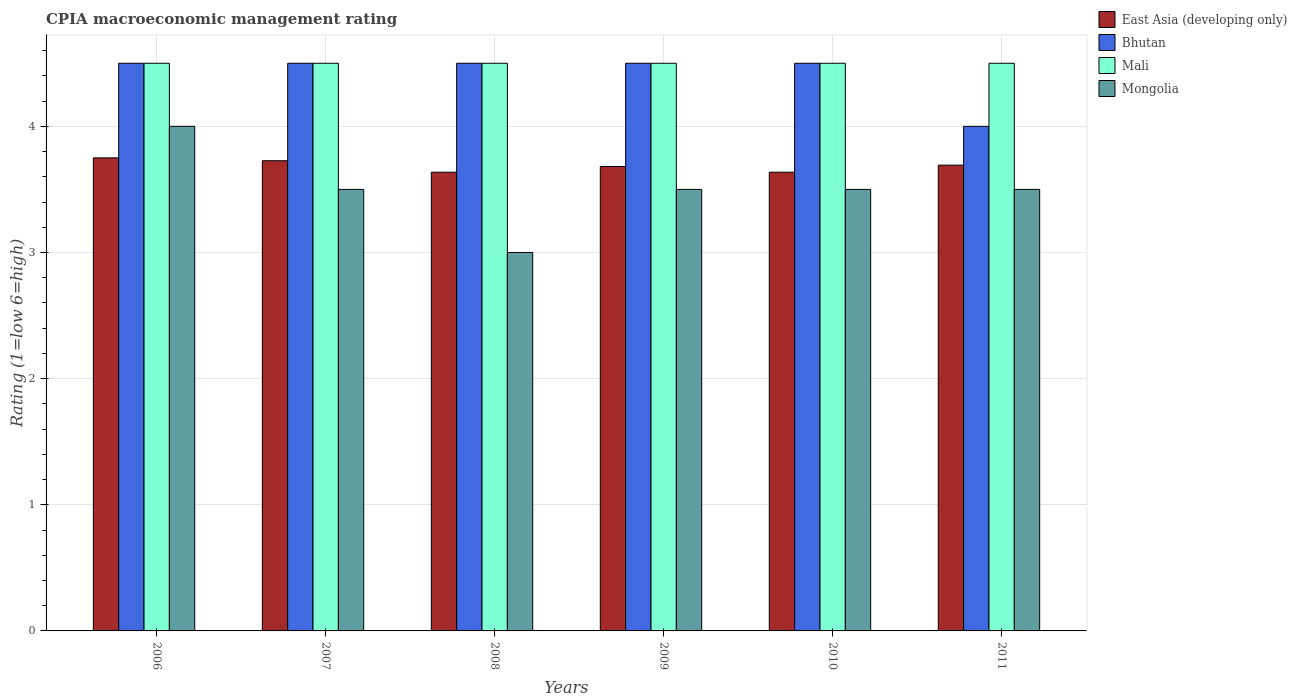How many groups of bars are there?
Offer a very short reply. 6. Are the number of bars per tick equal to the number of legend labels?
Ensure brevity in your answer.  Yes. Are the number of bars on each tick of the X-axis equal?
Provide a succinct answer. Yes. How many bars are there on the 4th tick from the right?
Your answer should be very brief. 4. In how many cases, is the number of bars for a given year not equal to the number of legend labels?
Provide a short and direct response. 0. What is the CPIA rating in East Asia (developing only) in 2006?
Provide a short and direct response. 3.75. Across all years, what is the minimum CPIA rating in Bhutan?
Offer a terse response. 4. In which year was the CPIA rating in Mongolia maximum?
Offer a very short reply. 2006. In which year was the CPIA rating in Mongolia minimum?
Give a very brief answer. 2008. What is the total CPIA rating in East Asia (developing only) in the graph?
Keep it short and to the point. 22.12. What is the difference between the CPIA rating in Mongolia in 2011 and the CPIA rating in Bhutan in 2007?
Your response must be concise. -1. In the year 2008, what is the difference between the CPIA rating in Mongolia and CPIA rating in Mali?
Keep it short and to the point. -1.5. In how many years, is the CPIA rating in Mali greater than 3?
Provide a short and direct response. 6. What is the ratio of the CPIA rating in Bhutan in 2008 to that in 2010?
Provide a succinct answer. 1. Is the CPIA rating in East Asia (developing only) in 2007 less than that in 2011?
Offer a terse response. No. Is the difference between the CPIA rating in Mongolia in 2010 and 2011 greater than the difference between the CPIA rating in Mali in 2010 and 2011?
Keep it short and to the point. No. What is the difference between the highest and the lowest CPIA rating in East Asia (developing only)?
Keep it short and to the point. 0.11. In how many years, is the CPIA rating in Mali greater than the average CPIA rating in Mali taken over all years?
Ensure brevity in your answer.  0. Is the sum of the CPIA rating in Mali in 2006 and 2009 greater than the maximum CPIA rating in Bhutan across all years?
Give a very brief answer. Yes. What does the 4th bar from the left in 2010 represents?
Keep it short and to the point. Mongolia. What does the 4th bar from the right in 2010 represents?
Offer a terse response. East Asia (developing only). Is it the case that in every year, the sum of the CPIA rating in East Asia (developing only) and CPIA rating in Mali is greater than the CPIA rating in Mongolia?
Your response must be concise. Yes. What is the difference between two consecutive major ticks on the Y-axis?
Your answer should be very brief. 1. Are the values on the major ticks of Y-axis written in scientific E-notation?
Your answer should be compact. No. Where does the legend appear in the graph?
Offer a terse response. Top right. What is the title of the graph?
Give a very brief answer. CPIA macroeconomic management rating. What is the label or title of the X-axis?
Provide a succinct answer. Years. What is the Rating (1=low 6=high) of East Asia (developing only) in 2006?
Offer a terse response. 3.75. What is the Rating (1=low 6=high) in Mongolia in 2006?
Provide a short and direct response. 4. What is the Rating (1=low 6=high) of East Asia (developing only) in 2007?
Ensure brevity in your answer.  3.73. What is the Rating (1=low 6=high) in Mongolia in 2007?
Give a very brief answer. 3.5. What is the Rating (1=low 6=high) in East Asia (developing only) in 2008?
Keep it short and to the point. 3.64. What is the Rating (1=low 6=high) of Bhutan in 2008?
Your answer should be very brief. 4.5. What is the Rating (1=low 6=high) of Mongolia in 2008?
Provide a succinct answer. 3. What is the Rating (1=low 6=high) in East Asia (developing only) in 2009?
Keep it short and to the point. 3.68. What is the Rating (1=low 6=high) of Mongolia in 2009?
Provide a succinct answer. 3.5. What is the Rating (1=low 6=high) of East Asia (developing only) in 2010?
Offer a terse response. 3.64. What is the Rating (1=low 6=high) in Bhutan in 2010?
Provide a short and direct response. 4.5. What is the Rating (1=low 6=high) in Mongolia in 2010?
Offer a terse response. 3.5. What is the Rating (1=low 6=high) in East Asia (developing only) in 2011?
Ensure brevity in your answer.  3.69. What is the Rating (1=low 6=high) of Mali in 2011?
Offer a terse response. 4.5. What is the Rating (1=low 6=high) of Mongolia in 2011?
Provide a succinct answer. 3.5. Across all years, what is the maximum Rating (1=low 6=high) in East Asia (developing only)?
Your response must be concise. 3.75. Across all years, what is the maximum Rating (1=low 6=high) of Bhutan?
Your answer should be compact. 4.5. Across all years, what is the minimum Rating (1=low 6=high) in East Asia (developing only)?
Keep it short and to the point. 3.64. Across all years, what is the minimum Rating (1=low 6=high) in Bhutan?
Your answer should be compact. 4. What is the total Rating (1=low 6=high) in East Asia (developing only) in the graph?
Provide a succinct answer. 22.12. What is the total Rating (1=low 6=high) in Mali in the graph?
Provide a short and direct response. 27. What is the difference between the Rating (1=low 6=high) in East Asia (developing only) in 2006 and that in 2007?
Make the answer very short. 0.02. What is the difference between the Rating (1=low 6=high) in Bhutan in 2006 and that in 2007?
Your response must be concise. 0. What is the difference between the Rating (1=low 6=high) in Mali in 2006 and that in 2007?
Your answer should be compact. 0. What is the difference between the Rating (1=low 6=high) in Mongolia in 2006 and that in 2007?
Your answer should be very brief. 0.5. What is the difference between the Rating (1=low 6=high) in East Asia (developing only) in 2006 and that in 2008?
Provide a succinct answer. 0.11. What is the difference between the Rating (1=low 6=high) in Bhutan in 2006 and that in 2008?
Provide a succinct answer. 0. What is the difference between the Rating (1=low 6=high) of East Asia (developing only) in 2006 and that in 2009?
Your answer should be very brief. 0.07. What is the difference between the Rating (1=low 6=high) of Mongolia in 2006 and that in 2009?
Give a very brief answer. 0.5. What is the difference between the Rating (1=low 6=high) in East Asia (developing only) in 2006 and that in 2010?
Offer a very short reply. 0.11. What is the difference between the Rating (1=low 6=high) of Bhutan in 2006 and that in 2010?
Offer a very short reply. 0. What is the difference between the Rating (1=low 6=high) in Mali in 2006 and that in 2010?
Offer a terse response. 0. What is the difference between the Rating (1=low 6=high) in Mongolia in 2006 and that in 2010?
Keep it short and to the point. 0.5. What is the difference between the Rating (1=low 6=high) of East Asia (developing only) in 2006 and that in 2011?
Give a very brief answer. 0.06. What is the difference between the Rating (1=low 6=high) of Bhutan in 2006 and that in 2011?
Give a very brief answer. 0.5. What is the difference between the Rating (1=low 6=high) of Mongolia in 2006 and that in 2011?
Ensure brevity in your answer.  0.5. What is the difference between the Rating (1=low 6=high) in East Asia (developing only) in 2007 and that in 2008?
Ensure brevity in your answer.  0.09. What is the difference between the Rating (1=low 6=high) in Bhutan in 2007 and that in 2008?
Offer a terse response. 0. What is the difference between the Rating (1=low 6=high) of Mali in 2007 and that in 2008?
Give a very brief answer. 0. What is the difference between the Rating (1=low 6=high) of Mongolia in 2007 and that in 2008?
Your answer should be compact. 0.5. What is the difference between the Rating (1=low 6=high) of East Asia (developing only) in 2007 and that in 2009?
Provide a short and direct response. 0.05. What is the difference between the Rating (1=low 6=high) of Mali in 2007 and that in 2009?
Your answer should be compact. 0. What is the difference between the Rating (1=low 6=high) in Mongolia in 2007 and that in 2009?
Your response must be concise. 0. What is the difference between the Rating (1=low 6=high) of East Asia (developing only) in 2007 and that in 2010?
Provide a short and direct response. 0.09. What is the difference between the Rating (1=low 6=high) in Mali in 2007 and that in 2010?
Keep it short and to the point. 0. What is the difference between the Rating (1=low 6=high) of East Asia (developing only) in 2007 and that in 2011?
Ensure brevity in your answer.  0.04. What is the difference between the Rating (1=low 6=high) in Bhutan in 2007 and that in 2011?
Your answer should be very brief. 0.5. What is the difference between the Rating (1=low 6=high) of Mali in 2007 and that in 2011?
Your answer should be very brief. 0. What is the difference between the Rating (1=low 6=high) in East Asia (developing only) in 2008 and that in 2009?
Provide a short and direct response. -0.05. What is the difference between the Rating (1=low 6=high) in Mali in 2008 and that in 2009?
Offer a terse response. 0. What is the difference between the Rating (1=low 6=high) of Mongolia in 2008 and that in 2009?
Ensure brevity in your answer.  -0.5. What is the difference between the Rating (1=low 6=high) of East Asia (developing only) in 2008 and that in 2010?
Keep it short and to the point. 0. What is the difference between the Rating (1=low 6=high) in Mali in 2008 and that in 2010?
Offer a terse response. 0. What is the difference between the Rating (1=low 6=high) in Mongolia in 2008 and that in 2010?
Provide a succinct answer. -0.5. What is the difference between the Rating (1=low 6=high) in East Asia (developing only) in 2008 and that in 2011?
Give a very brief answer. -0.06. What is the difference between the Rating (1=low 6=high) of East Asia (developing only) in 2009 and that in 2010?
Offer a terse response. 0.05. What is the difference between the Rating (1=low 6=high) in Bhutan in 2009 and that in 2010?
Ensure brevity in your answer.  0. What is the difference between the Rating (1=low 6=high) in Mali in 2009 and that in 2010?
Provide a short and direct response. 0. What is the difference between the Rating (1=low 6=high) of Mongolia in 2009 and that in 2010?
Keep it short and to the point. 0. What is the difference between the Rating (1=low 6=high) of East Asia (developing only) in 2009 and that in 2011?
Your answer should be compact. -0.01. What is the difference between the Rating (1=low 6=high) in Bhutan in 2009 and that in 2011?
Ensure brevity in your answer.  0.5. What is the difference between the Rating (1=low 6=high) in Mali in 2009 and that in 2011?
Your answer should be compact. 0. What is the difference between the Rating (1=low 6=high) of East Asia (developing only) in 2010 and that in 2011?
Your answer should be very brief. -0.06. What is the difference between the Rating (1=low 6=high) of Mongolia in 2010 and that in 2011?
Offer a very short reply. 0. What is the difference between the Rating (1=low 6=high) in East Asia (developing only) in 2006 and the Rating (1=low 6=high) in Bhutan in 2007?
Your answer should be compact. -0.75. What is the difference between the Rating (1=low 6=high) in East Asia (developing only) in 2006 and the Rating (1=low 6=high) in Mali in 2007?
Provide a succinct answer. -0.75. What is the difference between the Rating (1=low 6=high) in Mali in 2006 and the Rating (1=low 6=high) in Mongolia in 2007?
Your answer should be very brief. 1. What is the difference between the Rating (1=low 6=high) in East Asia (developing only) in 2006 and the Rating (1=low 6=high) in Bhutan in 2008?
Make the answer very short. -0.75. What is the difference between the Rating (1=low 6=high) in East Asia (developing only) in 2006 and the Rating (1=low 6=high) in Mali in 2008?
Offer a very short reply. -0.75. What is the difference between the Rating (1=low 6=high) in Mali in 2006 and the Rating (1=low 6=high) in Mongolia in 2008?
Make the answer very short. 1.5. What is the difference between the Rating (1=low 6=high) in East Asia (developing only) in 2006 and the Rating (1=low 6=high) in Bhutan in 2009?
Your answer should be very brief. -0.75. What is the difference between the Rating (1=low 6=high) of East Asia (developing only) in 2006 and the Rating (1=low 6=high) of Mali in 2009?
Keep it short and to the point. -0.75. What is the difference between the Rating (1=low 6=high) of East Asia (developing only) in 2006 and the Rating (1=low 6=high) of Mongolia in 2009?
Offer a terse response. 0.25. What is the difference between the Rating (1=low 6=high) in Bhutan in 2006 and the Rating (1=low 6=high) in Mali in 2009?
Give a very brief answer. 0. What is the difference between the Rating (1=low 6=high) in Bhutan in 2006 and the Rating (1=low 6=high) in Mongolia in 2009?
Give a very brief answer. 1. What is the difference between the Rating (1=low 6=high) of East Asia (developing only) in 2006 and the Rating (1=low 6=high) of Bhutan in 2010?
Your answer should be compact. -0.75. What is the difference between the Rating (1=low 6=high) in East Asia (developing only) in 2006 and the Rating (1=low 6=high) in Mali in 2010?
Offer a very short reply. -0.75. What is the difference between the Rating (1=low 6=high) of East Asia (developing only) in 2006 and the Rating (1=low 6=high) of Mongolia in 2010?
Offer a terse response. 0.25. What is the difference between the Rating (1=low 6=high) of Mali in 2006 and the Rating (1=low 6=high) of Mongolia in 2010?
Your answer should be very brief. 1. What is the difference between the Rating (1=low 6=high) of East Asia (developing only) in 2006 and the Rating (1=low 6=high) of Bhutan in 2011?
Ensure brevity in your answer.  -0.25. What is the difference between the Rating (1=low 6=high) of East Asia (developing only) in 2006 and the Rating (1=low 6=high) of Mali in 2011?
Give a very brief answer. -0.75. What is the difference between the Rating (1=low 6=high) in Bhutan in 2006 and the Rating (1=low 6=high) in Mali in 2011?
Your response must be concise. 0. What is the difference between the Rating (1=low 6=high) in Mali in 2006 and the Rating (1=low 6=high) in Mongolia in 2011?
Your response must be concise. 1. What is the difference between the Rating (1=low 6=high) in East Asia (developing only) in 2007 and the Rating (1=low 6=high) in Bhutan in 2008?
Your answer should be very brief. -0.77. What is the difference between the Rating (1=low 6=high) of East Asia (developing only) in 2007 and the Rating (1=low 6=high) of Mali in 2008?
Provide a succinct answer. -0.77. What is the difference between the Rating (1=low 6=high) of East Asia (developing only) in 2007 and the Rating (1=low 6=high) of Mongolia in 2008?
Provide a succinct answer. 0.73. What is the difference between the Rating (1=low 6=high) of Bhutan in 2007 and the Rating (1=low 6=high) of Mali in 2008?
Give a very brief answer. 0. What is the difference between the Rating (1=low 6=high) in Bhutan in 2007 and the Rating (1=low 6=high) in Mongolia in 2008?
Give a very brief answer. 1.5. What is the difference between the Rating (1=low 6=high) of East Asia (developing only) in 2007 and the Rating (1=low 6=high) of Bhutan in 2009?
Offer a very short reply. -0.77. What is the difference between the Rating (1=low 6=high) of East Asia (developing only) in 2007 and the Rating (1=low 6=high) of Mali in 2009?
Your answer should be very brief. -0.77. What is the difference between the Rating (1=low 6=high) in East Asia (developing only) in 2007 and the Rating (1=low 6=high) in Mongolia in 2009?
Make the answer very short. 0.23. What is the difference between the Rating (1=low 6=high) in Bhutan in 2007 and the Rating (1=low 6=high) in Mali in 2009?
Ensure brevity in your answer.  0. What is the difference between the Rating (1=low 6=high) of Bhutan in 2007 and the Rating (1=low 6=high) of Mongolia in 2009?
Provide a short and direct response. 1. What is the difference between the Rating (1=low 6=high) of Mali in 2007 and the Rating (1=low 6=high) of Mongolia in 2009?
Your answer should be compact. 1. What is the difference between the Rating (1=low 6=high) of East Asia (developing only) in 2007 and the Rating (1=low 6=high) of Bhutan in 2010?
Offer a very short reply. -0.77. What is the difference between the Rating (1=low 6=high) in East Asia (developing only) in 2007 and the Rating (1=low 6=high) in Mali in 2010?
Your response must be concise. -0.77. What is the difference between the Rating (1=low 6=high) of East Asia (developing only) in 2007 and the Rating (1=low 6=high) of Mongolia in 2010?
Make the answer very short. 0.23. What is the difference between the Rating (1=low 6=high) of Bhutan in 2007 and the Rating (1=low 6=high) of Mali in 2010?
Keep it short and to the point. 0. What is the difference between the Rating (1=low 6=high) in East Asia (developing only) in 2007 and the Rating (1=low 6=high) in Bhutan in 2011?
Offer a very short reply. -0.27. What is the difference between the Rating (1=low 6=high) in East Asia (developing only) in 2007 and the Rating (1=low 6=high) in Mali in 2011?
Keep it short and to the point. -0.77. What is the difference between the Rating (1=low 6=high) in East Asia (developing only) in 2007 and the Rating (1=low 6=high) in Mongolia in 2011?
Provide a succinct answer. 0.23. What is the difference between the Rating (1=low 6=high) of Bhutan in 2007 and the Rating (1=low 6=high) of Mali in 2011?
Ensure brevity in your answer.  0. What is the difference between the Rating (1=low 6=high) in Mali in 2007 and the Rating (1=low 6=high) in Mongolia in 2011?
Provide a succinct answer. 1. What is the difference between the Rating (1=low 6=high) in East Asia (developing only) in 2008 and the Rating (1=low 6=high) in Bhutan in 2009?
Make the answer very short. -0.86. What is the difference between the Rating (1=low 6=high) in East Asia (developing only) in 2008 and the Rating (1=low 6=high) in Mali in 2009?
Offer a terse response. -0.86. What is the difference between the Rating (1=low 6=high) in East Asia (developing only) in 2008 and the Rating (1=low 6=high) in Mongolia in 2009?
Give a very brief answer. 0.14. What is the difference between the Rating (1=low 6=high) in East Asia (developing only) in 2008 and the Rating (1=low 6=high) in Bhutan in 2010?
Keep it short and to the point. -0.86. What is the difference between the Rating (1=low 6=high) in East Asia (developing only) in 2008 and the Rating (1=low 6=high) in Mali in 2010?
Give a very brief answer. -0.86. What is the difference between the Rating (1=low 6=high) of East Asia (developing only) in 2008 and the Rating (1=low 6=high) of Mongolia in 2010?
Your answer should be very brief. 0.14. What is the difference between the Rating (1=low 6=high) in East Asia (developing only) in 2008 and the Rating (1=low 6=high) in Bhutan in 2011?
Make the answer very short. -0.36. What is the difference between the Rating (1=low 6=high) in East Asia (developing only) in 2008 and the Rating (1=low 6=high) in Mali in 2011?
Provide a short and direct response. -0.86. What is the difference between the Rating (1=low 6=high) of East Asia (developing only) in 2008 and the Rating (1=low 6=high) of Mongolia in 2011?
Provide a short and direct response. 0.14. What is the difference between the Rating (1=low 6=high) in Bhutan in 2008 and the Rating (1=low 6=high) in Mali in 2011?
Ensure brevity in your answer.  0. What is the difference between the Rating (1=low 6=high) in Mali in 2008 and the Rating (1=low 6=high) in Mongolia in 2011?
Provide a succinct answer. 1. What is the difference between the Rating (1=low 6=high) of East Asia (developing only) in 2009 and the Rating (1=low 6=high) of Bhutan in 2010?
Offer a very short reply. -0.82. What is the difference between the Rating (1=low 6=high) in East Asia (developing only) in 2009 and the Rating (1=low 6=high) in Mali in 2010?
Provide a succinct answer. -0.82. What is the difference between the Rating (1=low 6=high) in East Asia (developing only) in 2009 and the Rating (1=low 6=high) in Mongolia in 2010?
Make the answer very short. 0.18. What is the difference between the Rating (1=low 6=high) in Bhutan in 2009 and the Rating (1=low 6=high) in Mongolia in 2010?
Give a very brief answer. 1. What is the difference between the Rating (1=low 6=high) in East Asia (developing only) in 2009 and the Rating (1=low 6=high) in Bhutan in 2011?
Provide a succinct answer. -0.32. What is the difference between the Rating (1=low 6=high) in East Asia (developing only) in 2009 and the Rating (1=low 6=high) in Mali in 2011?
Provide a short and direct response. -0.82. What is the difference between the Rating (1=low 6=high) in East Asia (developing only) in 2009 and the Rating (1=low 6=high) in Mongolia in 2011?
Give a very brief answer. 0.18. What is the difference between the Rating (1=low 6=high) in Bhutan in 2009 and the Rating (1=low 6=high) in Mali in 2011?
Ensure brevity in your answer.  0. What is the difference between the Rating (1=low 6=high) in Bhutan in 2009 and the Rating (1=low 6=high) in Mongolia in 2011?
Keep it short and to the point. 1. What is the difference between the Rating (1=low 6=high) of Mali in 2009 and the Rating (1=low 6=high) of Mongolia in 2011?
Provide a succinct answer. 1. What is the difference between the Rating (1=low 6=high) of East Asia (developing only) in 2010 and the Rating (1=low 6=high) of Bhutan in 2011?
Provide a short and direct response. -0.36. What is the difference between the Rating (1=low 6=high) of East Asia (developing only) in 2010 and the Rating (1=low 6=high) of Mali in 2011?
Provide a short and direct response. -0.86. What is the difference between the Rating (1=low 6=high) of East Asia (developing only) in 2010 and the Rating (1=low 6=high) of Mongolia in 2011?
Your answer should be very brief. 0.14. What is the difference between the Rating (1=low 6=high) in Bhutan in 2010 and the Rating (1=low 6=high) in Mali in 2011?
Make the answer very short. 0. What is the difference between the Rating (1=low 6=high) in Bhutan in 2010 and the Rating (1=low 6=high) in Mongolia in 2011?
Your answer should be compact. 1. What is the average Rating (1=low 6=high) in East Asia (developing only) per year?
Your answer should be very brief. 3.69. What is the average Rating (1=low 6=high) of Bhutan per year?
Give a very brief answer. 4.42. What is the average Rating (1=low 6=high) in Mali per year?
Provide a short and direct response. 4.5. In the year 2006, what is the difference between the Rating (1=low 6=high) of East Asia (developing only) and Rating (1=low 6=high) of Bhutan?
Keep it short and to the point. -0.75. In the year 2006, what is the difference between the Rating (1=low 6=high) of East Asia (developing only) and Rating (1=low 6=high) of Mali?
Make the answer very short. -0.75. In the year 2006, what is the difference between the Rating (1=low 6=high) in East Asia (developing only) and Rating (1=low 6=high) in Mongolia?
Give a very brief answer. -0.25. In the year 2006, what is the difference between the Rating (1=low 6=high) of Mali and Rating (1=low 6=high) of Mongolia?
Make the answer very short. 0.5. In the year 2007, what is the difference between the Rating (1=low 6=high) of East Asia (developing only) and Rating (1=low 6=high) of Bhutan?
Your answer should be very brief. -0.77. In the year 2007, what is the difference between the Rating (1=low 6=high) of East Asia (developing only) and Rating (1=low 6=high) of Mali?
Ensure brevity in your answer.  -0.77. In the year 2007, what is the difference between the Rating (1=low 6=high) of East Asia (developing only) and Rating (1=low 6=high) of Mongolia?
Your answer should be very brief. 0.23. In the year 2007, what is the difference between the Rating (1=low 6=high) in Mali and Rating (1=low 6=high) in Mongolia?
Make the answer very short. 1. In the year 2008, what is the difference between the Rating (1=low 6=high) of East Asia (developing only) and Rating (1=low 6=high) of Bhutan?
Your answer should be very brief. -0.86. In the year 2008, what is the difference between the Rating (1=low 6=high) of East Asia (developing only) and Rating (1=low 6=high) of Mali?
Offer a terse response. -0.86. In the year 2008, what is the difference between the Rating (1=low 6=high) in East Asia (developing only) and Rating (1=low 6=high) in Mongolia?
Provide a short and direct response. 0.64. In the year 2008, what is the difference between the Rating (1=low 6=high) of Bhutan and Rating (1=low 6=high) of Mongolia?
Your response must be concise. 1.5. In the year 2008, what is the difference between the Rating (1=low 6=high) in Mali and Rating (1=low 6=high) in Mongolia?
Provide a short and direct response. 1.5. In the year 2009, what is the difference between the Rating (1=low 6=high) in East Asia (developing only) and Rating (1=low 6=high) in Bhutan?
Provide a succinct answer. -0.82. In the year 2009, what is the difference between the Rating (1=low 6=high) of East Asia (developing only) and Rating (1=low 6=high) of Mali?
Provide a short and direct response. -0.82. In the year 2009, what is the difference between the Rating (1=low 6=high) of East Asia (developing only) and Rating (1=low 6=high) of Mongolia?
Give a very brief answer. 0.18. In the year 2009, what is the difference between the Rating (1=low 6=high) of Bhutan and Rating (1=low 6=high) of Mali?
Offer a terse response. 0. In the year 2009, what is the difference between the Rating (1=low 6=high) in Bhutan and Rating (1=low 6=high) in Mongolia?
Your answer should be very brief. 1. In the year 2009, what is the difference between the Rating (1=low 6=high) of Mali and Rating (1=low 6=high) of Mongolia?
Provide a short and direct response. 1. In the year 2010, what is the difference between the Rating (1=low 6=high) in East Asia (developing only) and Rating (1=low 6=high) in Bhutan?
Your response must be concise. -0.86. In the year 2010, what is the difference between the Rating (1=low 6=high) in East Asia (developing only) and Rating (1=low 6=high) in Mali?
Your response must be concise. -0.86. In the year 2010, what is the difference between the Rating (1=low 6=high) of East Asia (developing only) and Rating (1=low 6=high) of Mongolia?
Your response must be concise. 0.14. In the year 2010, what is the difference between the Rating (1=low 6=high) of Bhutan and Rating (1=low 6=high) of Mali?
Provide a succinct answer. 0. In the year 2011, what is the difference between the Rating (1=low 6=high) in East Asia (developing only) and Rating (1=low 6=high) in Bhutan?
Your answer should be very brief. -0.31. In the year 2011, what is the difference between the Rating (1=low 6=high) in East Asia (developing only) and Rating (1=low 6=high) in Mali?
Provide a succinct answer. -0.81. In the year 2011, what is the difference between the Rating (1=low 6=high) in East Asia (developing only) and Rating (1=low 6=high) in Mongolia?
Provide a succinct answer. 0.19. In the year 2011, what is the difference between the Rating (1=low 6=high) in Bhutan and Rating (1=low 6=high) in Mali?
Ensure brevity in your answer.  -0.5. In the year 2011, what is the difference between the Rating (1=low 6=high) of Bhutan and Rating (1=low 6=high) of Mongolia?
Provide a succinct answer. 0.5. What is the ratio of the Rating (1=low 6=high) of Bhutan in 2006 to that in 2007?
Ensure brevity in your answer.  1. What is the ratio of the Rating (1=low 6=high) of East Asia (developing only) in 2006 to that in 2008?
Your answer should be compact. 1.03. What is the ratio of the Rating (1=low 6=high) of East Asia (developing only) in 2006 to that in 2009?
Offer a very short reply. 1.02. What is the ratio of the Rating (1=low 6=high) of Bhutan in 2006 to that in 2009?
Offer a terse response. 1. What is the ratio of the Rating (1=low 6=high) of Mali in 2006 to that in 2009?
Your answer should be very brief. 1. What is the ratio of the Rating (1=low 6=high) of East Asia (developing only) in 2006 to that in 2010?
Ensure brevity in your answer.  1.03. What is the ratio of the Rating (1=low 6=high) of Bhutan in 2006 to that in 2010?
Offer a terse response. 1. What is the ratio of the Rating (1=low 6=high) in Mali in 2006 to that in 2010?
Your answer should be compact. 1. What is the ratio of the Rating (1=low 6=high) in East Asia (developing only) in 2006 to that in 2011?
Provide a succinct answer. 1.02. What is the ratio of the Rating (1=low 6=high) in East Asia (developing only) in 2007 to that in 2008?
Your answer should be very brief. 1.02. What is the ratio of the Rating (1=low 6=high) of Bhutan in 2007 to that in 2008?
Offer a terse response. 1. What is the ratio of the Rating (1=low 6=high) in Mali in 2007 to that in 2008?
Your answer should be very brief. 1. What is the ratio of the Rating (1=low 6=high) in Mongolia in 2007 to that in 2008?
Offer a very short reply. 1.17. What is the ratio of the Rating (1=low 6=high) of East Asia (developing only) in 2007 to that in 2009?
Ensure brevity in your answer.  1.01. What is the ratio of the Rating (1=low 6=high) of Bhutan in 2007 to that in 2009?
Offer a very short reply. 1. What is the ratio of the Rating (1=low 6=high) of Mongolia in 2007 to that in 2009?
Provide a short and direct response. 1. What is the ratio of the Rating (1=low 6=high) of East Asia (developing only) in 2007 to that in 2010?
Ensure brevity in your answer.  1.02. What is the ratio of the Rating (1=low 6=high) in Mali in 2007 to that in 2010?
Provide a short and direct response. 1. What is the ratio of the Rating (1=low 6=high) of East Asia (developing only) in 2007 to that in 2011?
Make the answer very short. 1.01. What is the ratio of the Rating (1=low 6=high) in Bhutan in 2007 to that in 2011?
Give a very brief answer. 1.12. What is the ratio of the Rating (1=low 6=high) in Mongolia in 2007 to that in 2011?
Give a very brief answer. 1. What is the ratio of the Rating (1=low 6=high) in Mali in 2008 to that in 2009?
Your answer should be very brief. 1. What is the ratio of the Rating (1=low 6=high) in Mongolia in 2008 to that in 2009?
Keep it short and to the point. 0.86. What is the ratio of the Rating (1=low 6=high) in Bhutan in 2008 to that in 2010?
Provide a succinct answer. 1. What is the ratio of the Rating (1=low 6=high) in Mali in 2008 to that in 2010?
Your answer should be very brief. 1. What is the ratio of the Rating (1=low 6=high) of Mongolia in 2008 to that in 2010?
Provide a succinct answer. 0.86. What is the ratio of the Rating (1=low 6=high) in East Asia (developing only) in 2008 to that in 2011?
Keep it short and to the point. 0.98. What is the ratio of the Rating (1=low 6=high) of Mali in 2008 to that in 2011?
Offer a terse response. 1. What is the ratio of the Rating (1=low 6=high) in East Asia (developing only) in 2009 to that in 2010?
Make the answer very short. 1.01. What is the ratio of the Rating (1=low 6=high) in Bhutan in 2009 to that in 2010?
Give a very brief answer. 1. What is the ratio of the Rating (1=low 6=high) in Bhutan in 2009 to that in 2011?
Offer a terse response. 1.12. What is the ratio of the Rating (1=low 6=high) of Mongolia in 2009 to that in 2011?
Provide a succinct answer. 1. What is the ratio of the Rating (1=low 6=high) of East Asia (developing only) in 2010 to that in 2011?
Your answer should be very brief. 0.98. What is the ratio of the Rating (1=low 6=high) of Mongolia in 2010 to that in 2011?
Offer a terse response. 1. What is the difference between the highest and the second highest Rating (1=low 6=high) in East Asia (developing only)?
Provide a short and direct response. 0.02. What is the difference between the highest and the second highest Rating (1=low 6=high) of Bhutan?
Your answer should be very brief. 0. What is the difference between the highest and the second highest Rating (1=low 6=high) of Mongolia?
Provide a succinct answer. 0.5. What is the difference between the highest and the lowest Rating (1=low 6=high) in East Asia (developing only)?
Provide a succinct answer. 0.11. What is the difference between the highest and the lowest Rating (1=low 6=high) of Bhutan?
Your answer should be compact. 0.5. What is the difference between the highest and the lowest Rating (1=low 6=high) of Mali?
Keep it short and to the point. 0. 